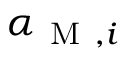Convert formula to latex. <formula><loc_0><loc_0><loc_500><loc_500>\alpha _ { M , i }</formula> 